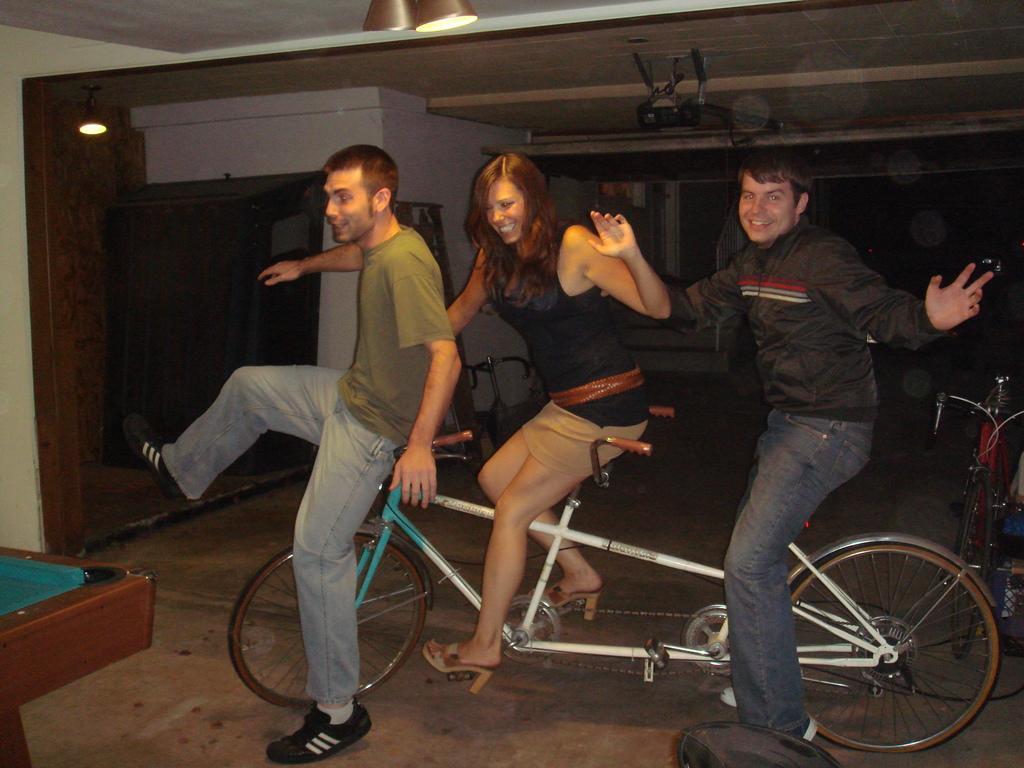In one or two sentences, can you explain what this image depicts? This is the picture of three people sitting on the bicycle and among them one is a women and behind them there is a projector and a light to the wall. 